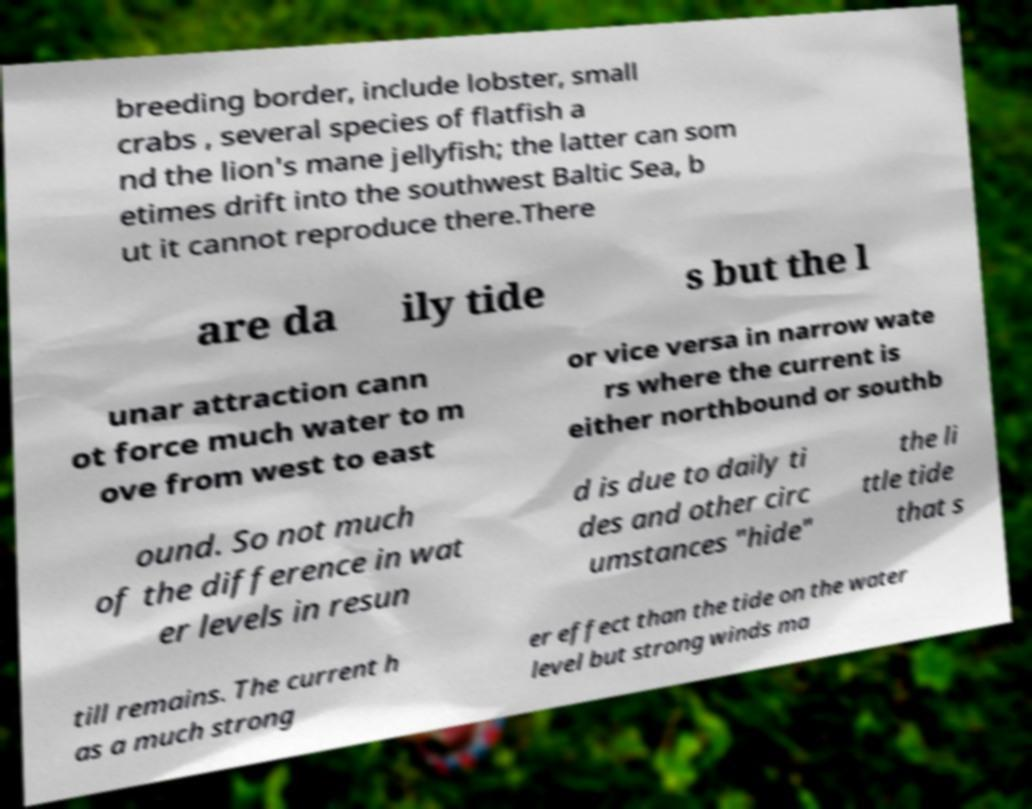Please read and relay the text visible in this image. What does it say? breeding border, include lobster, small crabs , several species of flatfish a nd the lion's mane jellyfish; the latter can som etimes drift into the southwest Baltic Sea, b ut it cannot reproduce there.There are da ily tide s but the l unar attraction cann ot force much water to m ove from west to east or vice versa in narrow wate rs where the current is either northbound or southb ound. So not much of the difference in wat er levels in resun d is due to daily ti des and other circ umstances "hide" the li ttle tide that s till remains. The current h as a much strong er effect than the tide on the water level but strong winds ma 